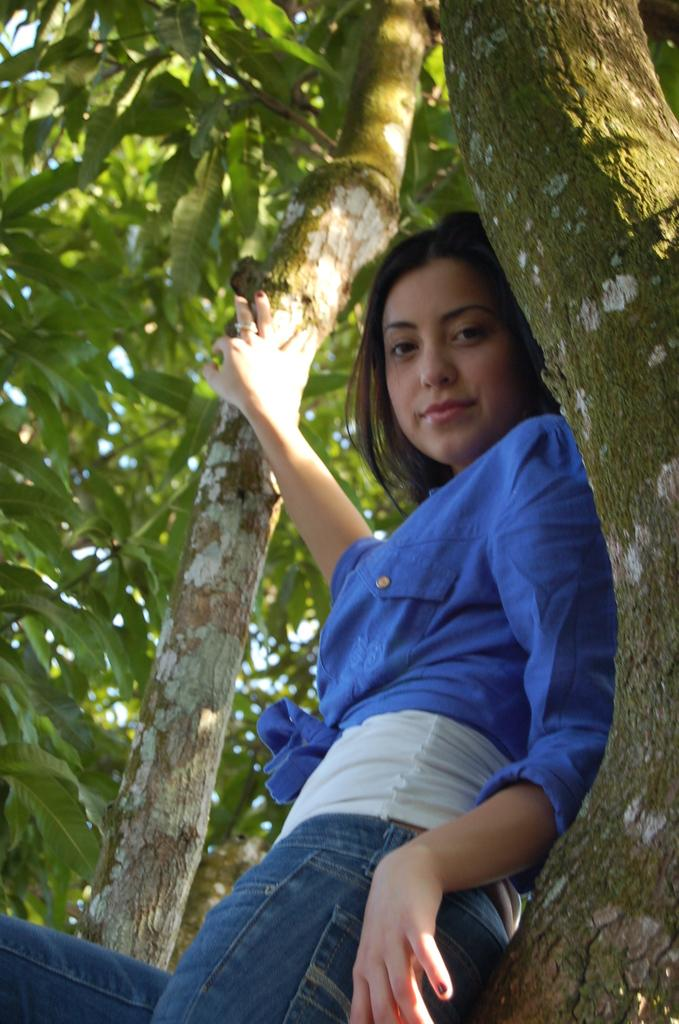Who is the main subject in the image? There is a woman in the image. What is the woman doing in the image? The woman is posing for a photo. How is the woman positioned in relation to the tree trunks? The woman is leaning towards a tree trunk and holding another tree trunk with her right hand. What grade did the woman receive for her performance in the image? There is no indication of a performance or grade in the image; it simply shows a woman posing for a photo. 